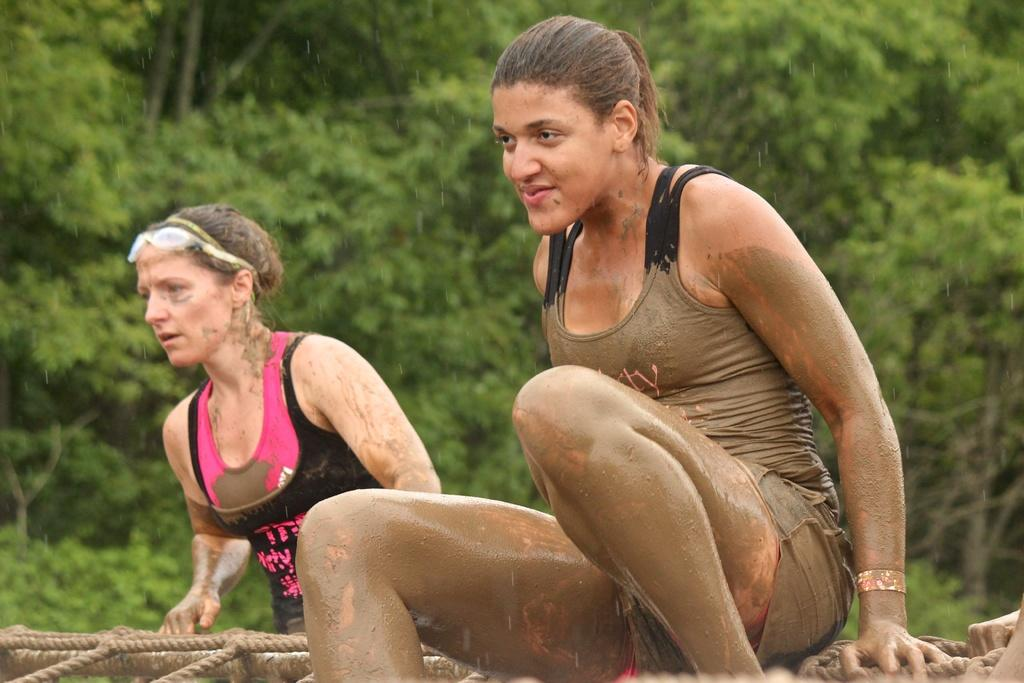What type of people can be seen in the image? There are women in the image. What natural elements are present in the image? There are trees in the image. Can you describe the attire of one of the women? A woman is wearing sunglasses. What objects can be seen in the image that are used for tying or securing? There are ropes visible in the image. What substance is visible on a woman's body? There is mud on a woman's body. What day of the week is depicted in the image? The day of the week is not visible or mentioned in the image. What type of plant can be seen growing near the women? There is no specific plant mentioned or visible in the image. 